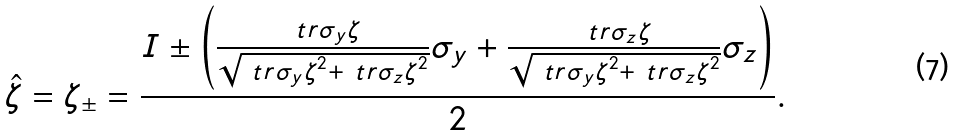Convert formula to latex. <formula><loc_0><loc_0><loc_500><loc_500>\hat { \zeta } = \zeta _ { \pm } = \frac { I \pm \left ( \frac { \ t r { \sigma _ { y } \zeta } } { \sqrt { \ t r { \sigma _ { y } \zeta } ^ { 2 } + \ t r { \sigma _ { z } \zeta } ^ { 2 } } } \sigma _ { y } + \frac { \ t r { \sigma _ { z } \zeta } } { \sqrt { \ t r { \sigma _ { y } \zeta } ^ { 2 } + \ t r { \sigma _ { z } \zeta } ^ { 2 } } } \sigma _ { z } \right ) } { 2 } .</formula> 